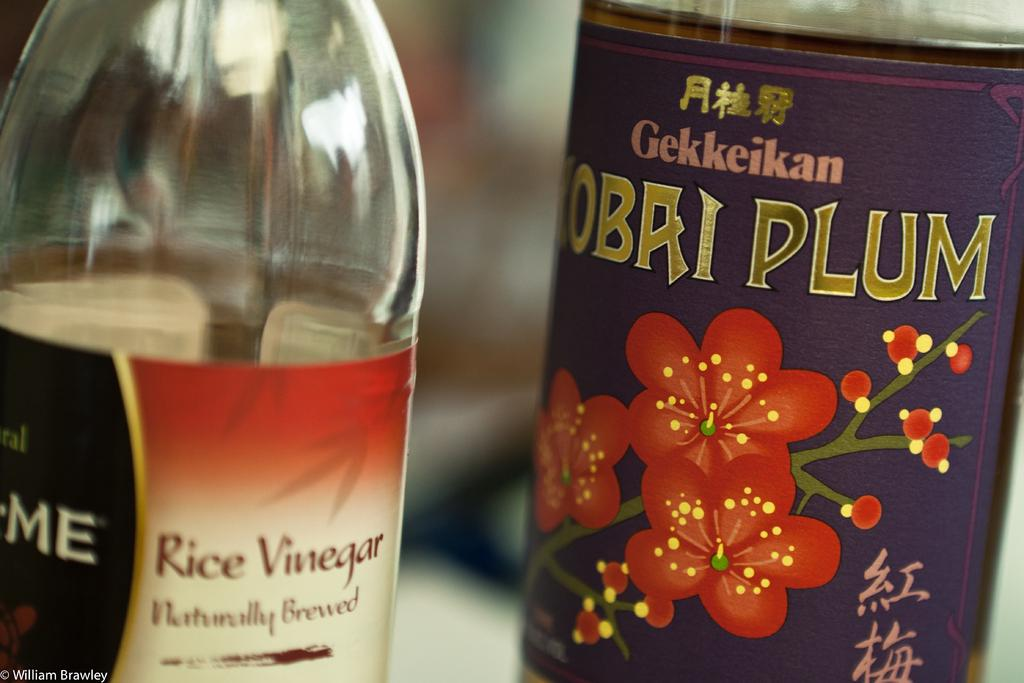<image>
Create a compact narrative representing the image presented. A colourful tin of plums sits beside a bottle of rice vinegar. 